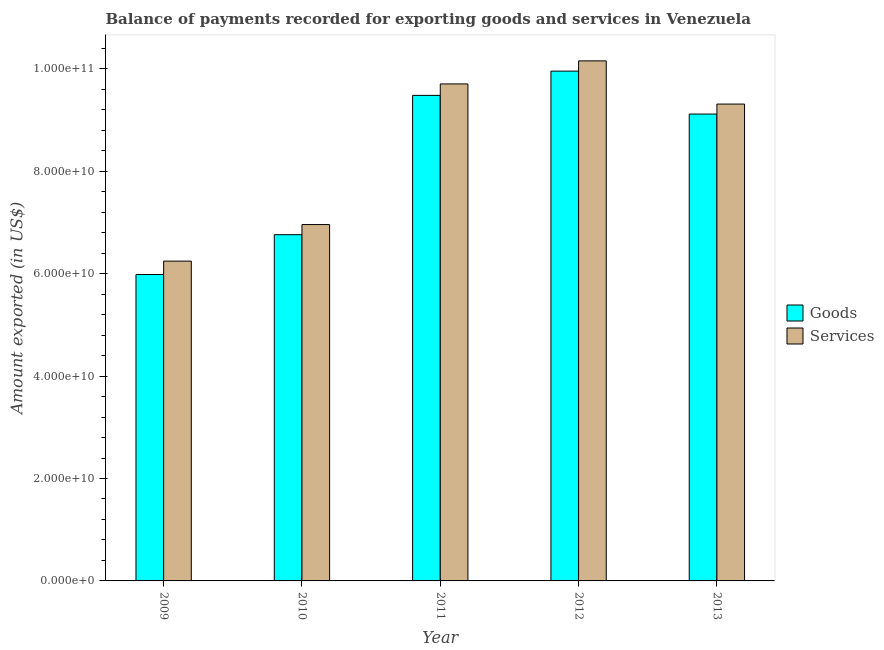Are the number of bars per tick equal to the number of legend labels?
Offer a terse response. Yes. Are the number of bars on each tick of the X-axis equal?
Your answer should be very brief. Yes. How many bars are there on the 4th tick from the left?
Your answer should be very brief. 2. What is the amount of goods exported in 2009?
Your answer should be very brief. 5.98e+1. Across all years, what is the maximum amount of goods exported?
Keep it short and to the point. 9.95e+1. Across all years, what is the minimum amount of services exported?
Give a very brief answer. 6.24e+1. In which year was the amount of goods exported maximum?
Your answer should be compact. 2012. In which year was the amount of services exported minimum?
Offer a terse response. 2009. What is the total amount of services exported in the graph?
Keep it short and to the point. 4.24e+11. What is the difference between the amount of goods exported in 2010 and that in 2012?
Make the answer very short. -3.19e+1. What is the difference between the amount of services exported in 2012 and the amount of goods exported in 2010?
Your answer should be compact. 3.20e+1. What is the average amount of services exported per year?
Your answer should be compact. 8.47e+1. In the year 2012, what is the difference between the amount of services exported and amount of goods exported?
Provide a succinct answer. 0. What is the ratio of the amount of goods exported in 2011 to that in 2012?
Your answer should be very brief. 0.95. What is the difference between the highest and the second highest amount of services exported?
Your answer should be compact. 4.50e+09. What is the difference between the highest and the lowest amount of services exported?
Your answer should be compact. 3.91e+1. What does the 2nd bar from the left in 2009 represents?
Your answer should be very brief. Services. What does the 1st bar from the right in 2011 represents?
Make the answer very short. Services. How many bars are there?
Keep it short and to the point. 10. How many years are there in the graph?
Your response must be concise. 5. Does the graph contain any zero values?
Give a very brief answer. No. Does the graph contain grids?
Ensure brevity in your answer.  No. Where does the legend appear in the graph?
Your answer should be compact. Center right. How many legend labels are there?
Your response must be concise. 2. What is the title of the graph?
Ensure brevity in your answer.  Balance of payments recorded for exporting goods and services in Venezuela. What is the label or title of the X-axis?
Make the answer very short. Year. What is the label or title of the Y-axis?
Provide a short and direct response. Amount exported (in US$). What is the Amount exported (in US$) in Goods in 2009?
Provide a short and direct response. 5.98e+1. What is the Amount exported (in US$) in Services in 2009?
Offer a terse response. 6.24e+1. What is the Amount exported (in US$) of Goods in 2010?
Make the answer very short. 6.76e+1. What is the Amount exported (in US$) in Services in 2010?
Ensure brevity in your answer.  6.96e+1. What is the Amount exported (in US$) of Goods in 2011?
Keep it short and to the point. 9.48e+1. What is the Amount exported (in US$) of Services in 2011?
Make the answer very short. 9.70e+1. What is the Amount exported (in US$) of Goods in 2012?
Ensure brevity in your answer.  9.95e+1. What is the Amount exported (in US$) in Services in 2012?
Your answer should be very brief. 1.02e+11. What is the Amount exported (in US$) in Goods in 2013?
Provide a succinct answer. 9.12e+1. What is the Amount exported (in US$) in Services in 2013?
Provide a succinct answer. 9.31e+1. Across all years, what is the maximum Amount exported (in US$) in Goods?
Offer a very short reply. 9.95e+1. Across all years, what is the maximum Amount exported (in US$) in Services?
Your answer should be very brief. 1.02e+11. Across all years, what is the minimum Amount exported (in US$) of Goods?
Your response must be concise. 5.98e+1. Across all years, what is the minimum Amount exported (in US$) of Services?
Offer a very short reply. 6.24e+1. What is the total Amount exported (in US$) in Goods in the graph?
Your answer should be compact. 4.13e+11. What is the total Amount exported (in US$) of Services in the graph?
Your response must be concise. 4.24e+11. What is the difference between the Amount exported (in US$) in Goods in 2009 and that in 2010?
Make the answer very short. -7.77e+09. What is the difference between the Amount exported (in US$) in Services in 2009 and that in 2010?
Keep it short and to the point. -7.14e+09. What is the difference between the Amount exported (in US$) in Goods in 2009 and that in 2011?
Your response must be concise. -3.50e+1. What is the difference between the Amount exported (in US$) of Services in 2009 and that in 2011?
Your answer should be very brief. -3.46e+1. What is the difference between the Amount exported (in US$) in Goods in 2009 and that in 2012?
Provide a succinct answer. -3.97e+1. What is the difference between the Amount exported (in US$) in Services in 2009 and that in 2012?
Your answer should be compact. -3.91e+1. What is the difference between the Amount exported (in US$) of Goods in 2009 and that in 2013?
Provide a succinct answer. -3.13e+1. What is the difference between the Amount exported (in US$) of Services in 2009 and that in 2013?
Your answer should be very brief. -3.07e+1. What is the difference between the Amount exported (in US$) of Goods in 2010 and that in 2011?
Make the answer very short. -2.72e+1. What is the difference between the Amount exported (in US$) of Services in 2010 and that in 2011?
Your answer should be compact. -2.75e+1. What is the difference between the Amount exported (in US$) of Goods in 2010 and that in 2012?
Offer a very short reply. -3.19e+1. What is the difference between the Amount exported (in US$) in Services in 2010 and that in 2012?
Keep it short and to the point. -3.20e+1. What is the difference between the Amount exported (in US$) of Goods in 2010 and that in 2013?
Offer a terse response. -2.36e+1. What is the difference between the Amount exported (in US$) of Services in 2010 and that in 2013?
Offer a terse response. -2.35e+1. What is the difference between the Amount exported (in US$) of Goods in 2011 and that in 2012?
Keep it short and to the point. -4.74e+09. What is the difference between the Amount exported (in US$) of Services in 2011 and that in 2012?
Offer a very short reply. -4.50e+09. What is the difference between the Amount exported (in US$) of Goods in 2011 and that in 2013?
Give a very brief answer. 3.64e+09. What is the difference between the Amount exported (in US$) of Services in 2011 and that in 2013?
Your answer should be very brief. 3.93e+09. What is the difference between the Amount exported (in US$) in Goods in 2012 and that in 2013?
Make the answer very short. 8.39e+09. What is the difference between the Amount exported (in US$) in Services in 2012 and that in 2013?
Your response must be concise. 8.43e+09. What is the difference between the Amount exported (in US$) in Goods in 2009 and the Amount exported (in US$) in Services in 2010?
Your response must be concise. -9.75e+09. What is the difference between the Amount exported (in US$) of Goods in 2009 and the Amount exported (in US$) of Services in 2011?
Give a very brief answer. -3.72e+1. What is the difference between the Amount exported (in US$) in Goods in 2009 and the Amount exported (in US$) in Services in 2012?
Offer a terse response. -4.17e+1. What is the difference between the Amount exported (in US$) of Goods in 2009 and the Amount exported (in US$) of Services in 2013?
Provide a short and direct response. -3.33e+1. What is the difference between the Amount exported (in US$) of Goods in 2010 and the Amount exported (in US$) of Services in 2011?
Ensure brevity in your answer.  -2.94e+1. What is the difference between the Amount exported (in US$) in Goods in 2010 and the Amount exported (in US$) in Services in 2012?
Make the answer very short. -3.39e+1. What is the difference between the Amount exported (in US$) in Goods in 2010 and the Amount exported (in US$) in Services in 2013?
Your response must be concise. -2.55e+1. What is the difference between the Amount exported (in US$) of Goods in 2011 and the Amount exported (in US$) of Services in 2012?
Give a very brief answer. -6.74e+09. What is the difference between the Amount exported (in US$) in Goods in 2011 and the Amount exported (in US$) in Services in 2013?
Your answer should be compact. 1.70e+09. What is the difference between the Amount exported (in US$) of Goods in 2012 and the Amount exported (in US$) of Services in 2013?
Give a very brief answer. 6.44e+09. What is the average Amount exported (in US$) in Goods per year?
Provide a short and direct response. 8.26e+1. What is the average Amount exported (in US$) of Services per year?
Offer a very short reply. 8.47e+1. In the year 2009, what is the difference between the Amount exported (in US$) of Goods and Amount exported (in US$) of Services?
Keep it short and to the point. -2.62e+09. In the year 2010, what is the difference between the Amount exported (in US$) in Goods and Amount exported (in US$) in Services?
Your answer should be very brief. -1.98e+09. In the year 2011, what is the difference between the Amount exported (in US$) in Goods and Amount exported (in US$) in Services?
Keep it short and to the point. -2.24e+09. In the year 2012, what is the difference between the Amount exported (in US$) of Goods and Amount exported (in US$) of Services?
Offer a very short reply. -2.00e+09. In the year 2013, what is the difference between the Amount exported (in US$) of Goods and Amount exported (in US$) of Services?
Your answer should be compact. -1.95e+09. What is the ratio of the Amount exported (in US$) of Goods in 2009 to that in 2010?
Offer a terse response. 0.89. What is the ratio of the Amount exported (in US$) in Services in 2009 to that in 2010?
Your response must be concise. 0.9. What is the ratio of the Amount exported (in US$) of Goods in 2009 to that in 2011?
Provide a succinct answer. 0.63. What is the ratio of the Amount exported (in US$) of Services in 2009 to that in 2011?
Give a very brief answer. 0.64. What is the ratio of the Amount exported (in US$) in Goods in 2009 to that in 2012?
Your answer should be very brief. 0.6. What is the ratio of the Amount exported (in US$) in Services in 2009 to that in 2012?
Your answer should be very brief. 0.61. What is the ratio of the Amount exported (in US$) of Goods in 2009 to that in 2013?
Give a very brief answer. 0.66. What is the ratio of the Amount exported (in US$) in Services in 2009 to that in 2013?
Offer a very short reply. 0.67. What is the ratio of the Amount exported (in US$) of Goods in 2010 to that in 2011?
Ensure brevity in your answer.  0.71. What is the ratio of the Amount exported (in US$) in Services in 2010 to that in 2011?
Your response must be concise. 0.72. What is the ratio of the Amount exported (in US$) in Goods in 2010 to that in 2012?
Offer a very short reply. 0.68. What is the ratio of the Amount exported (in US$) of Services in 2010 to that in 2012?
Make the answer very short. 0.69. What is the ratio of the Amount exported (in US$) of Goods in 2010 to that in 2013?
Your answer should be compact. 0.74. What is the ratio of the Amount exported (in US$) of Services in 2010 to that in 2013?
Keep it short and to the point. 0.75. What is the ratio of the Amount exported (in US$) of Goods in 2011 to that in 2012?
Your response must be concise. 0.95. What is the ratio of the Amount exported (in US$) of Services in 2011 to that in 2012?
Offer a very short reply. 0.96. What is the ratio of the Amount exported (in US$) in Goods in 2011 to that in 2013?
Provide a succinct answer. 1.04. What is the ratio of the Amount exported (in US$) of Services in 2011 to that in 2013?
Offer a very short reply. 1.04. What is the ratio of the Amount exported (in US$) in Goods in 2012 to that in 2013?
Your response must be concise. 1.09. What is the ratio of the Amount exported (in US$) in Services in 2012 to that in 2013?
Offer a terse response. 1.09. What is the difference between the highest and the second highest Amount exported (in US$) in Goods?
Provide a short and direct response. 4.74e+09. What is the difference between the highest and the second highest Amount exported (in US$) of Services?
Your response must be concise. 4.50e+09. What is the difference between the highest and the lowest Amount exported (in US$) of Goods?
Offer a terse response. 3.97e+1. What is the difference between the highest and the lowest Amount exported (in US$) of Services?
Keep it short and to the point. 3.91e+1. 